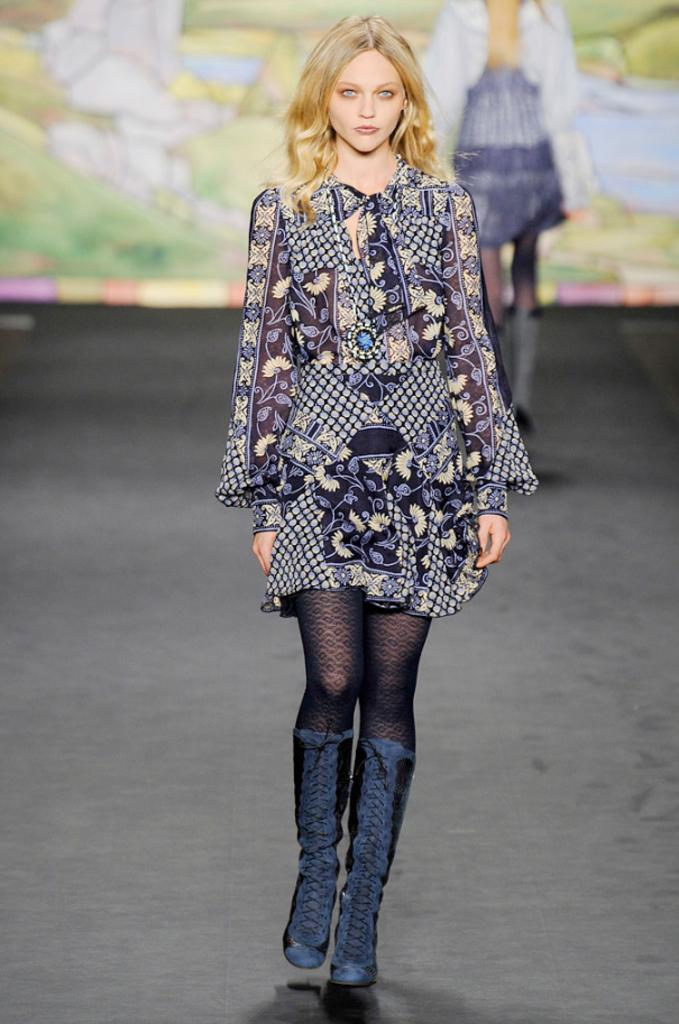Who is the main subject in the image? There is a girl in the image. What is the girl doing in the image? The girl is doing a ramp walk on the stage. Are there any other people visible in the image? Yes, there is another girl standing on the stage in the background. What can be seen in the background of the image? There is a screen visible in the background. What type of star can be seen in the image? There is no star visible in the image. How many arches are present in the image? There are no arches present in the image. 